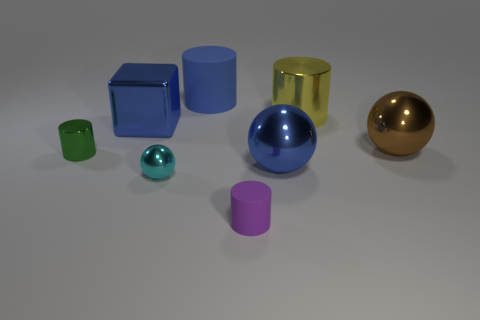What number of large yellow metal things are the same shape as the cyan metal object? 0 